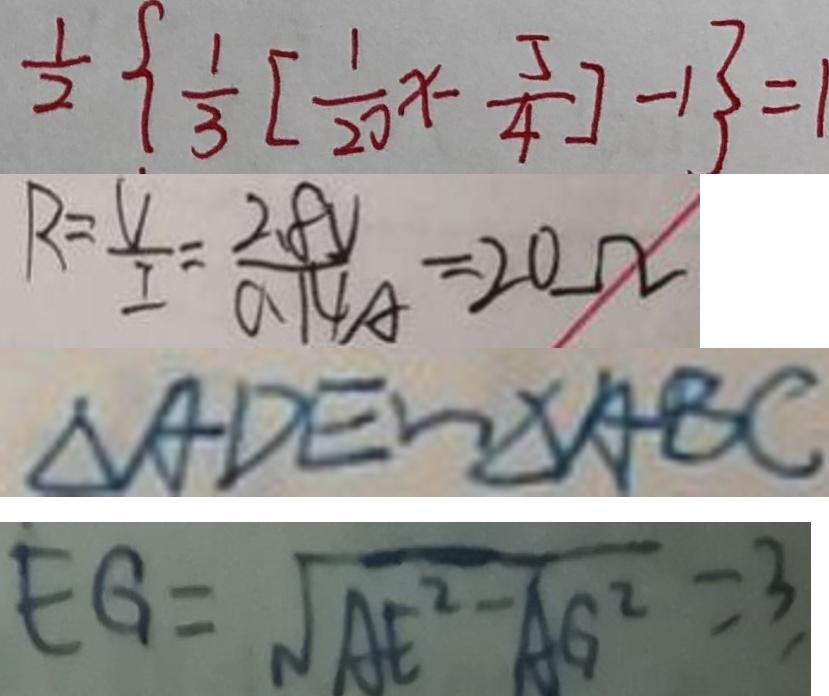Convert formula to latex. <formula><loc_0><loc_0><loc_500><loc_500>\frac { 1 } { 2 } \{ \frac { 1 } { 3 } [ \frac { 1 } { 2 0 } x - \frac { 5 } { 4 } ] - 1 \} = 1 
 R = \frac { V } { I } = \frac { 2 . 8 V } { 0 . 1 4 A } = 2 0 \Omega 
 \Delta A D E \sim \Delta A B C 
 E G = \sqrt { A E ^ { 2 } - A G ^ { 2 } } = 3</formula> 